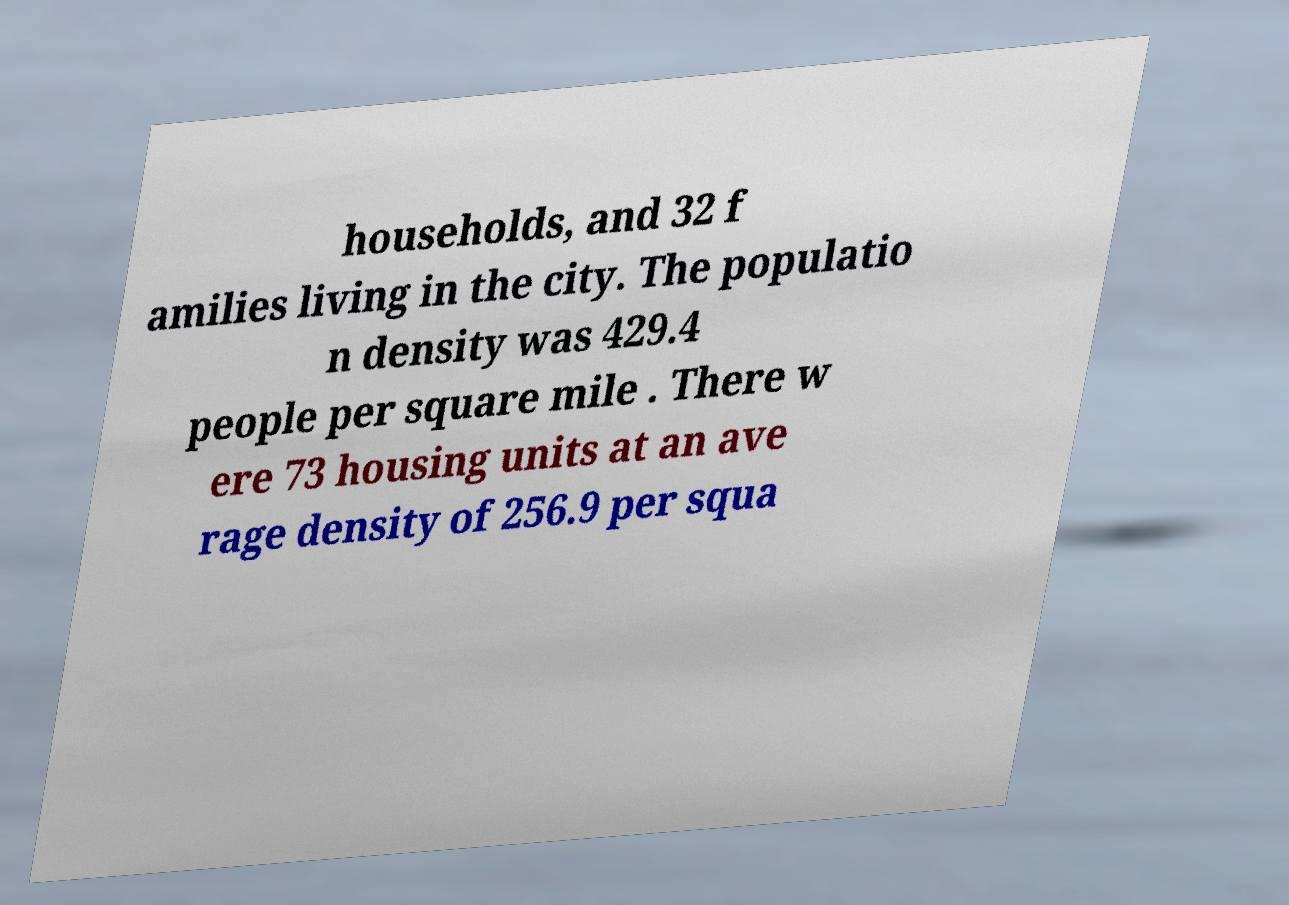Could you extract and type out the text from this image? households, and 32 f amilies living in the city. The populatio n density was 429.4 people per square mile . There w ere 73 housing units at an ave rage density of 256.9 per squa 